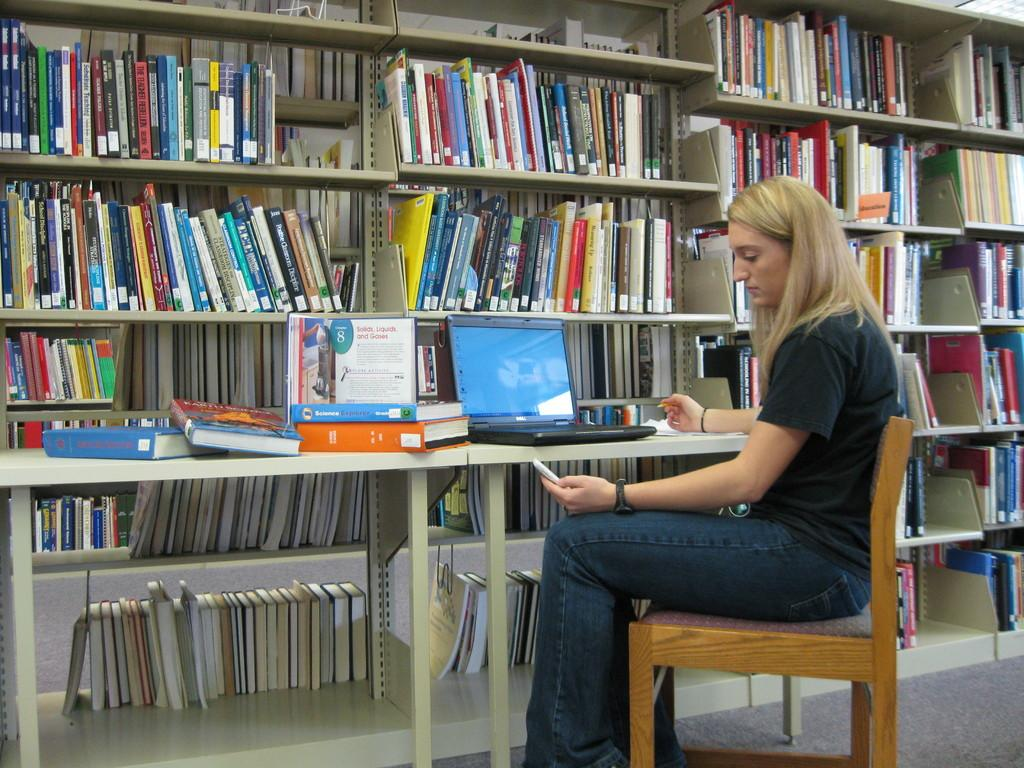What is the woman doing in the image? The woman is sitting on a wooden chair. What is the woman holding in her hand? The woman is holding a mobile phone in her left hand. What can be seen on the table in the image? There are books and a laptop on the table. What type of furniture is visible in the image besides the chair? There is a table and a bookshelf in the image. How does the woman add numbers on the mobile phone in the image? The image does not show the woman performing any addition on the mobile phone; she is simply holding it in her hand. 